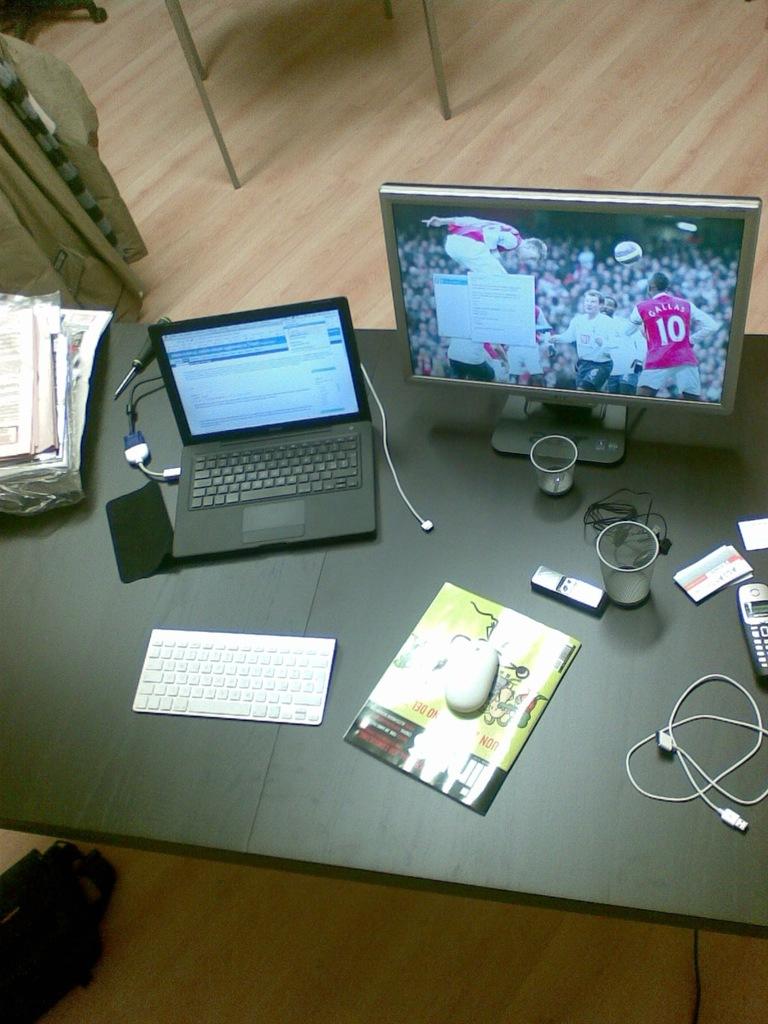Is player 10 on their screen?
Give a very brief answer. Yes. 